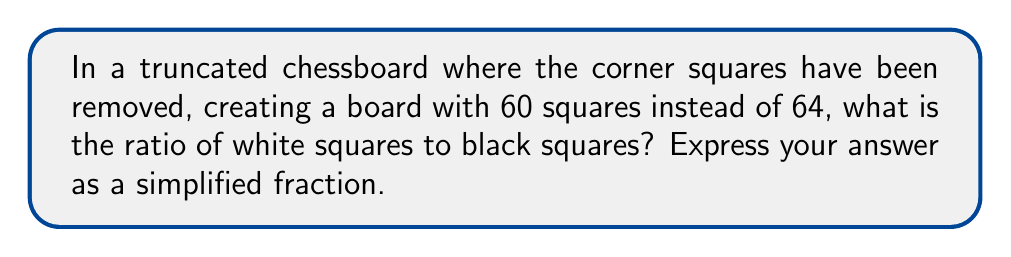What is the answer to this math problem? Let's approach this step-by-step:

1) A standard chessboard has 8 rows and 8 columns, totaling 64 squares.

2) The squares alternate in color, creating a checkered pattern. In a standard board, there are equal numbers of white and black squares: 32 each.

3) In this truncated board, we've removed the corner squares. Let's consider which corners were removed:

   - Top-left: White
   - Top-right: Black
   - Bottom-left: Black
   - Bottom-right: White

4) So, we've removed 2 white squares and 2 black squares.

5) Let's calculate the remaining squares of each color:
   
   White squares: $32 - 2 = 30$
   Black squares: $32 - 2 = 30$

6) The ratio of white to black squares is thus $30:30$, which can be simplified to $1:1$.

7) In fractional form, this is $\frac{30}{30} = \frac{1}{1}$
Answer: $\frac{1}{1}$ 